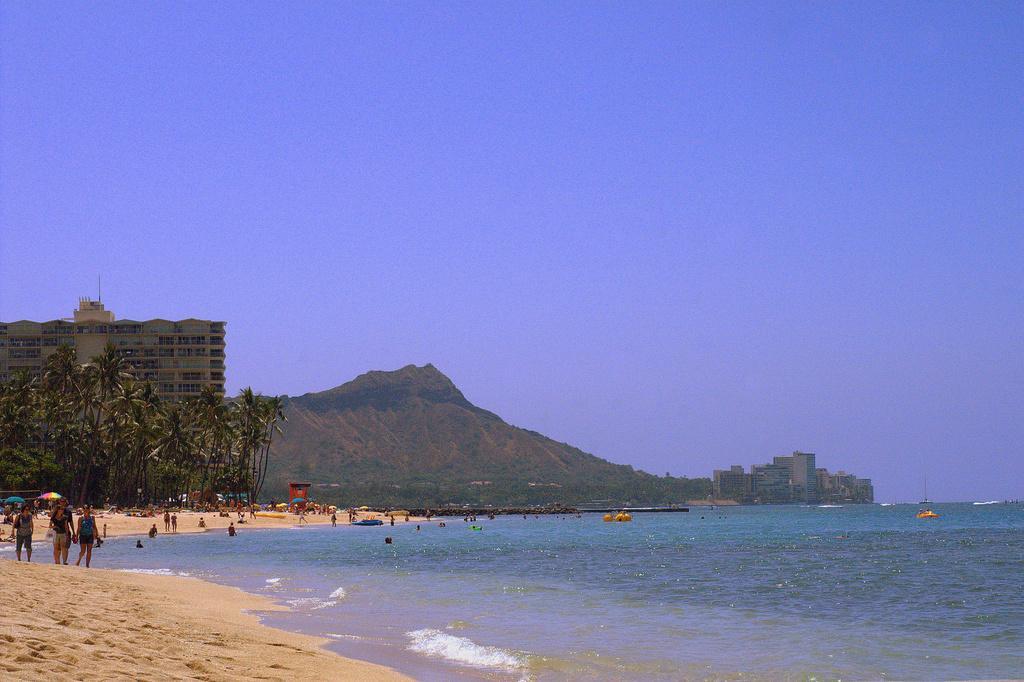How would you summarize this image in a sentence or two? In this image we can see a beach, there are some persons and boats on the beach, we can see some people standing in the sand, there are some umbrellas, trees, buildings and mountains, in the background we can see the sky. 